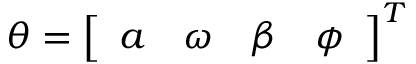Convert formula to latex. <formula><loc_0><loc_0><loc_500><loc_500>\theta = \left [ \begin{array} { c c c c } { a } & { \omega } & { \beta } & { \phi } \end{array} \right ] ^ { T }</formula> 